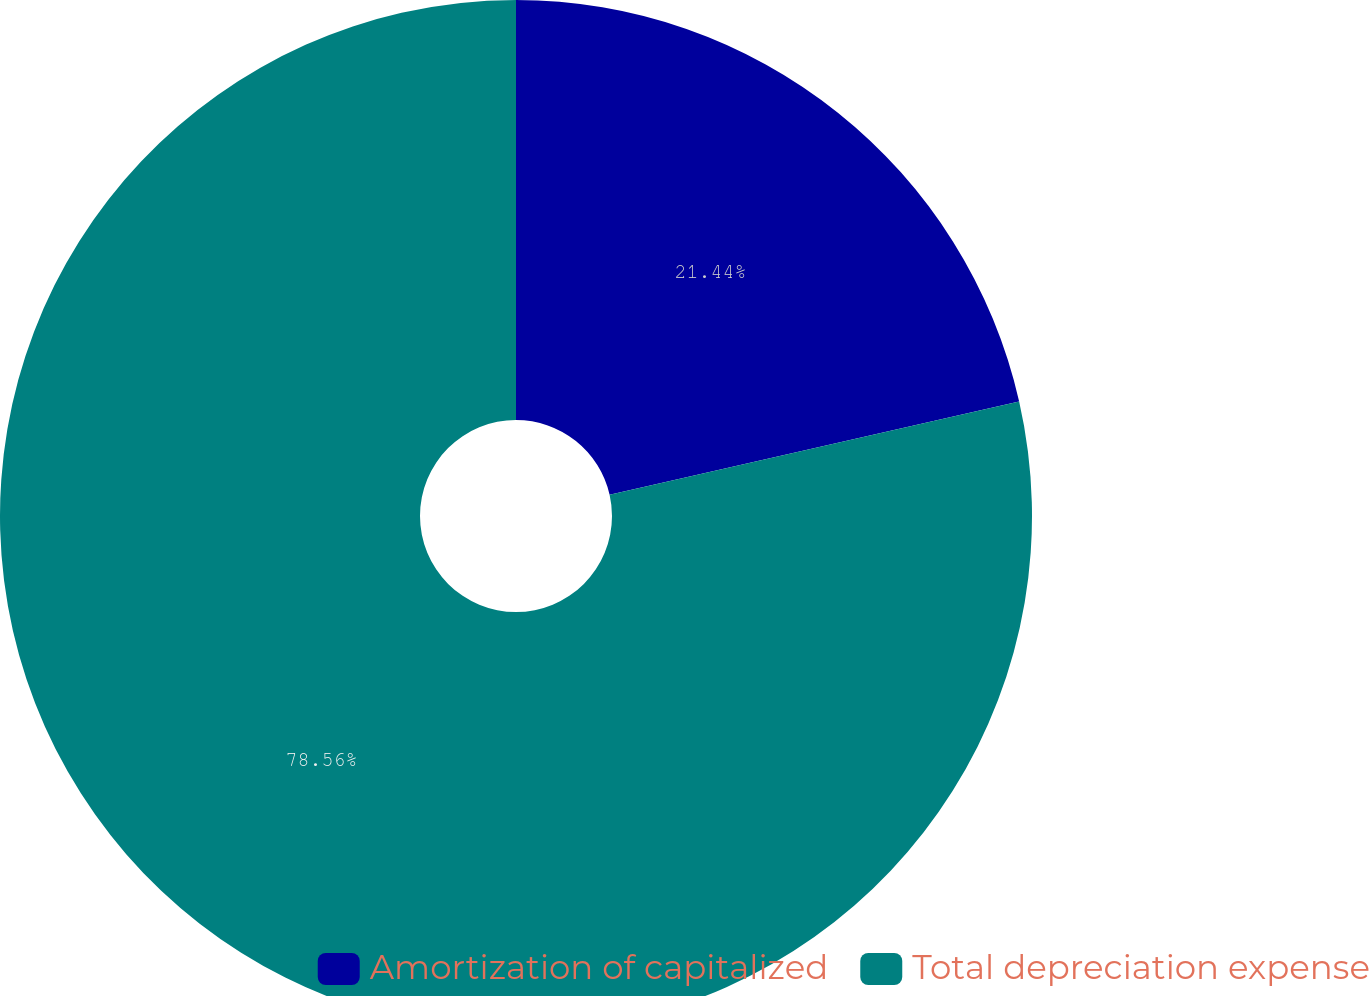<chart> <loc_0><loc_0><loc_500><loc_500><pie_chart><fcel>Amortization of capitalized<fcel>Total depreciation expense<nl><fcel>21.44%<fcel>78.56%<nl></chart> 